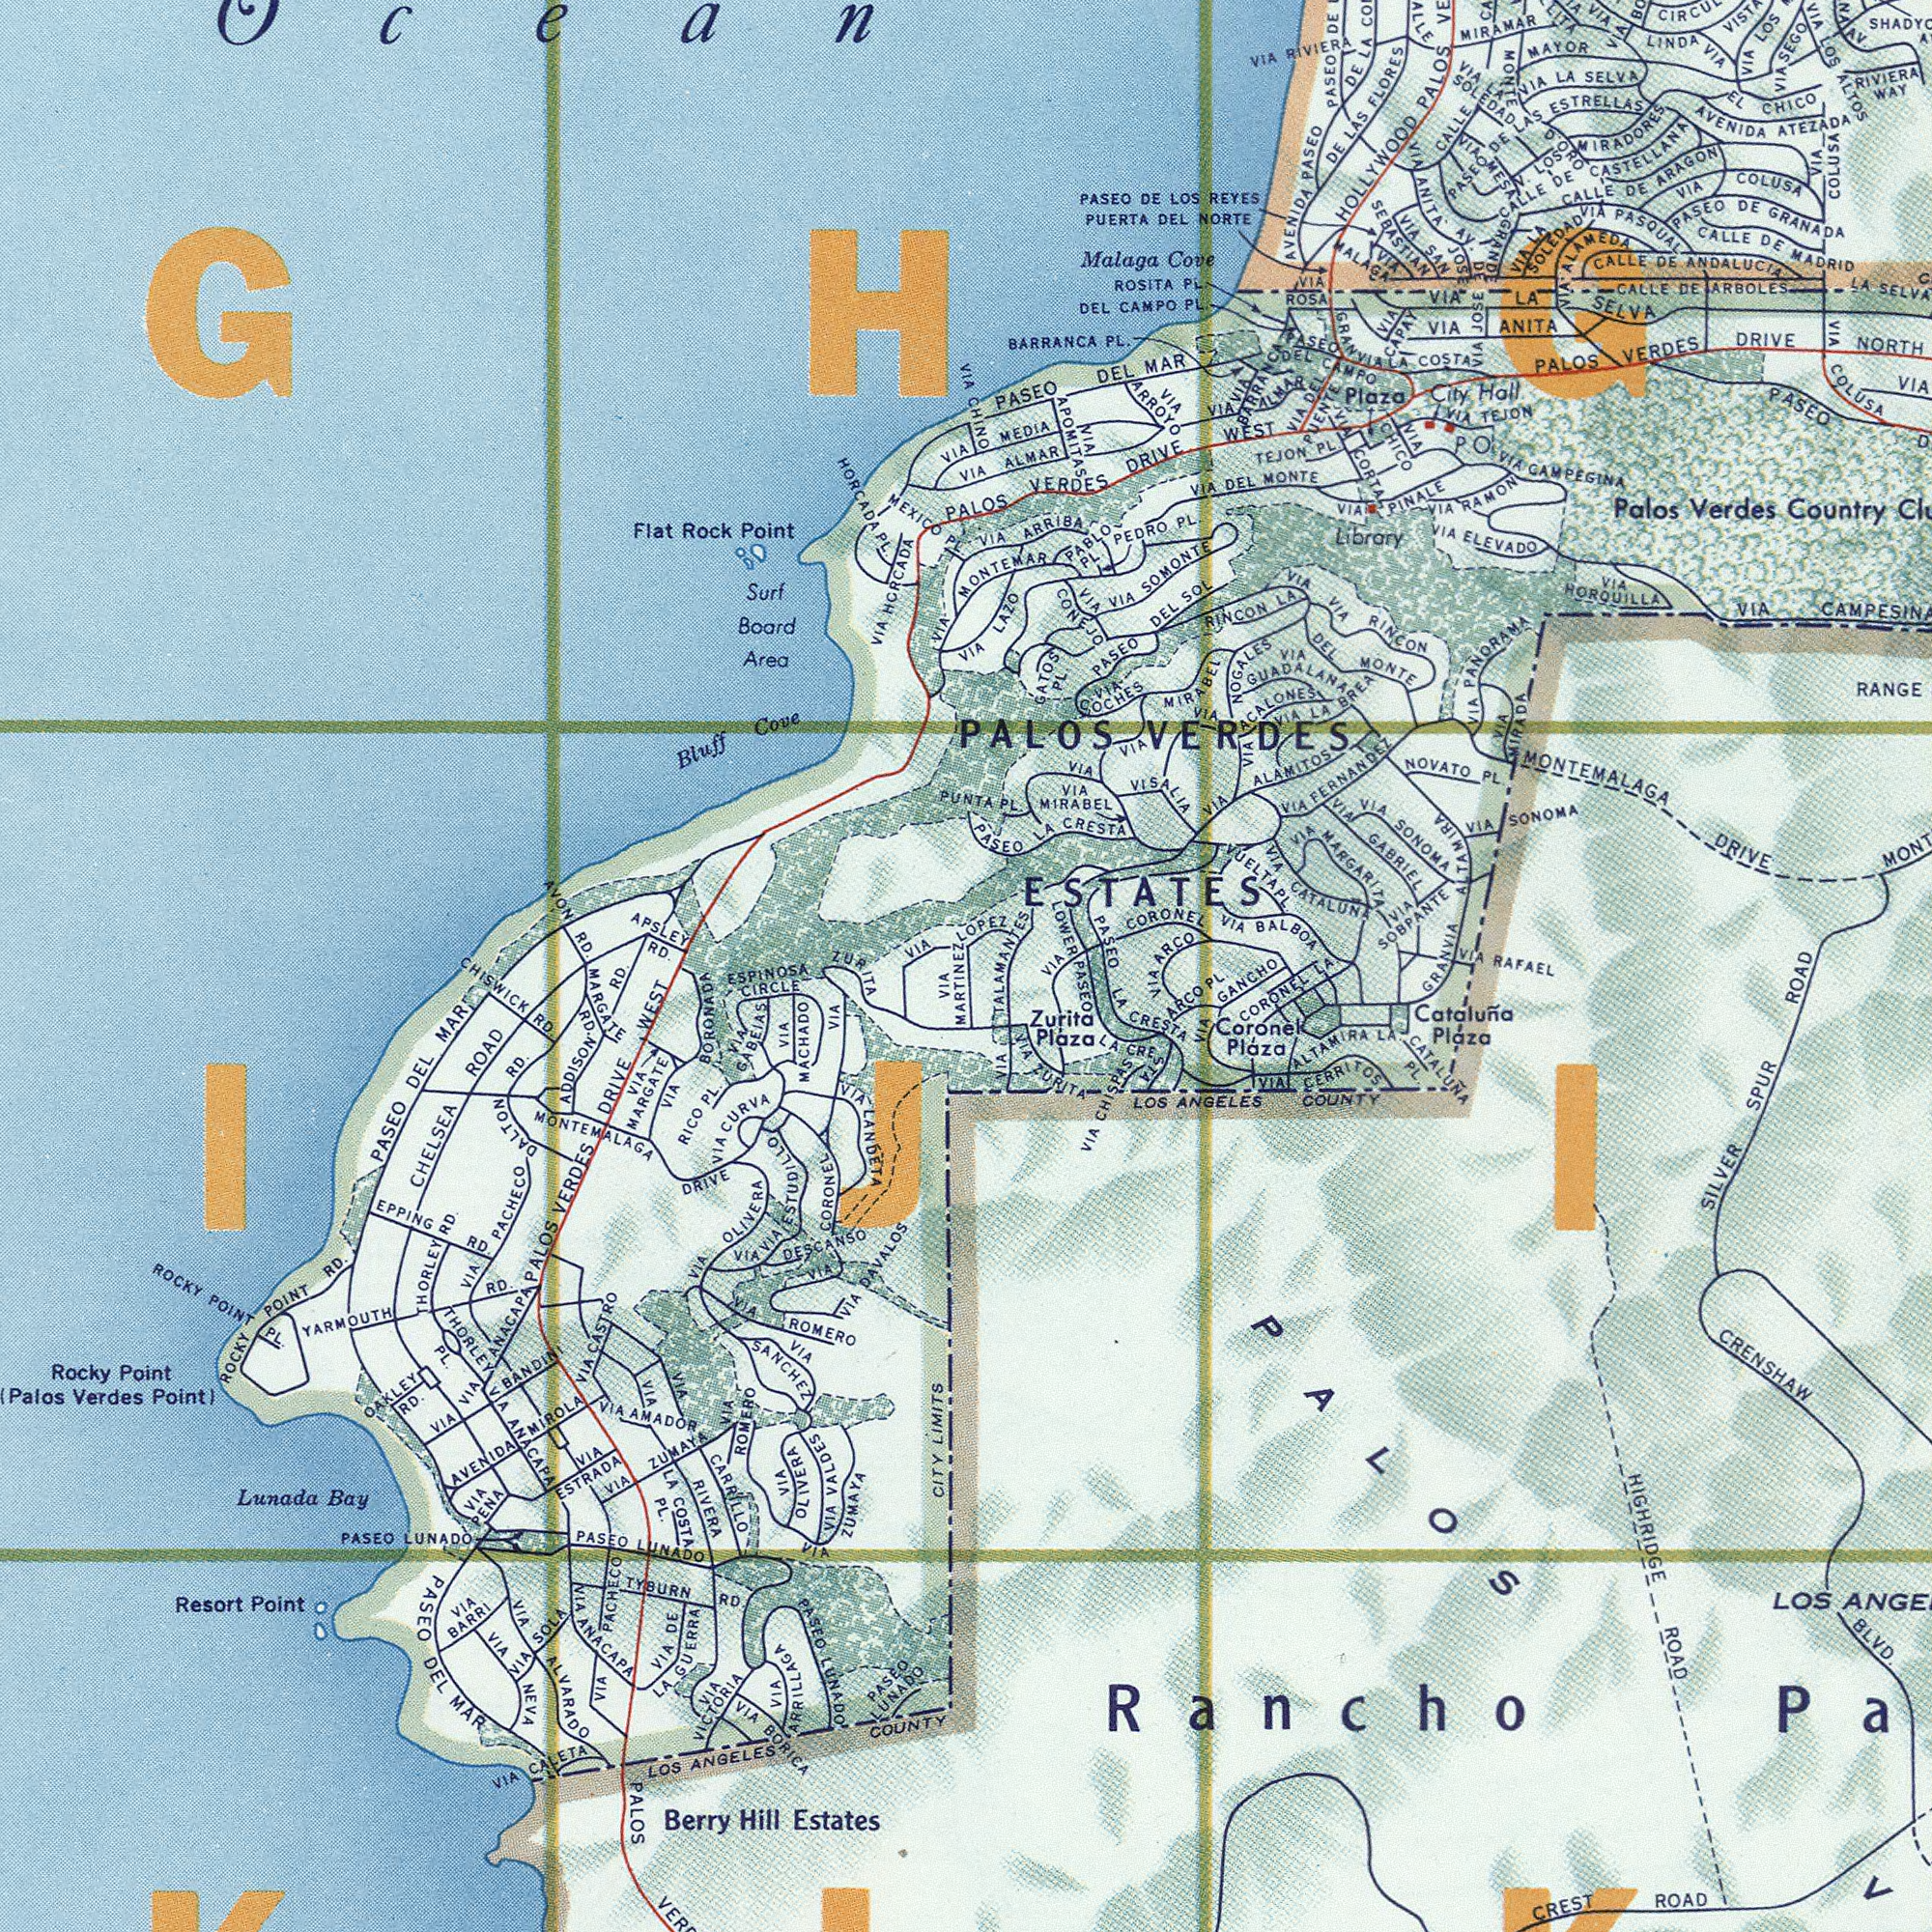What text is shown in the bottom-left quadrant? VIA VIA BORONADA VIA ALVARADO VIAAMADOR VIA RIVERA PASEO DEL MART VIA ANACAPA PALOS VERDES DRIVE WEST DALTON RD. Berry Hill Estates Lunada Bay ROCKY POINT RD. VIA CARRILLO VIA ROMERO VIA CORONEL OAKLEY RD. PASEO LUNADOL VIA BANDIN RICO PL. Rocky Point (Palos Verdes Point) CHELSEA ROAD VIA ZUMAYA VIA DAVALOS YARMOUTH RD. VIA DE PASEO LUNADO VIA MACHADO LOS ANGELES COUNTY MONTEMALAGA DRIVE CITY LIMITS VIA PACHECO PASEO LUNADO VIA OLIVERA LA COSTA PL. THORLEY RD. CHISWICK RD. EPPING RD. VIA SOLA VIA ZUMAYA PASEO DEL MAR TYBURN RD. PASEO LUNADO VIA PENA VIA ARRILLAGA ROCKY POINT PL. VIA ROMERO PALOS VER VIA OLIVERA VIA GABEIAS VIA PACHECO ADDISON RD. Resort Point VIA MARGATE VIA SANCHEL THORLEL PL. VIA ESTRADA VIA CASTRO VIA CURVA VIA NEVA VIA BARRI VIA ANACAPA VIA ANACAPA AVENIDA MIROLA MARGATE RD. ###IJI### VIA CALETA VIA BORICA VIA VICTORIA LA GUERRA VIA VALDES VIA ESTUDILLO VIA DESCANSO VIA LANDETA ESPINOSA CIRCLE VIA MARTINEZ What text is shown in the top-left quadrant? AVON RD. Surf Board Area Flat Rock Point Bluff Cove VIA HCRCADA APSLEY RD. ZU VIA MEXICO PL. PUNTA VIA HORCADA PL. VIA Ocean ###GHG### What text is shown in the bottom-right quadrant? LA CRESTA 4TA HIGHRIDGE ROAD Catoluña Pidza CRENSHAW BLVD. SILVER SPUR ROAD LOS LOS ANGELES COUNTY VIA TURITA CREST ROAD CATALUNA PL. VVAL CERRITOS Coronel Plaza Zurita Plaza VIA CHISPAS CORONEL LA VIA PASEO LA CRESTA ALTAMIRA LA. Rancho VIA GANCHO PALOS ARCO PL. What text is visible in the upper-right corner? MEDIA PL. ONTEMAR PALOS VERDES DRIVE WEST LOPEZ MONTEMALAGA DRIVE HOLLYWOOD PALOS VIA GABRIEL VIA CAMPESINA MIRAMAR VIA BALBOA VIA CATALUNA DE LAS FLORES CALLE DE ARBOLES PASEO DE LAS ESTRELLAS VIA COLUSA Palos Verdes Country Malaga Cove VUELTAPL VIA SONOMA VIA HOROUILLA VIA ALAMITOS PASEO DE GRANADA VIA GUADALAN VIA COLUSA VIA ARRIBA VIA RIVIERA PUERTA DEL NORTE PASEO DEL MAR AVENIDA PASEO VIA LAZO VIA CORTA PALOS VERDES DRIVE NORTH BARRANCA PL. VIA EL CHICO VIA ANITA VIA LA SELVA Librory VIA SOMONTE CALLE DE ARAGON PEDRO PL. VIA LOS PASEC VIA ALMAR CALLE DE ANDALUCIA CALLE MAYOR VIA MIRABEL LA VIA DEL MONTE NOVATO PL. VIA DEL MONTE PASEO PASEO LA CRESTA PASEO DEL SOL PASEO DE LOS REYES DEL CAMPO PL. VIA PINALE CALLE DE MADRID Plaza City Hall AVENIDA ATEZADA VIA SOBPANTE DE LA ARCO VIA ELEVADO VIA MIRABEL PASEOR DE DE VIA PASQUAL VIA PANDRAMA RINCON LA VIA FERNANDEL VIA LINDA VISTA VIA ROSA ROSITA PL. TALAMANTES LOWER VIA VIA ALAMEDA VIA LA SOLEDAD VIA COLUSA VIA LOS ALTOS AV. RIVIERA WAY VIA SEGO CIRCUL VIA MONTE VIA LA SELVA VIA LA SOLEDAD D ORO V. LOS MIRADORES CALLE DE CASTELLANA VIA MRSA GARNDE VIA ANITA AV. VIA JOSE VIA CHICO TEJON PL. VIA ALMAR VIA BARRANCA PASEO VIA DEL PUENTE PALOS VERDES ESTATES PABLO PL VIA APOMITAS VIA CHINO VIA ARROYO DE JOSE VIA SAN SEBASTIAN VIA MALAGA VIA CAPAY GRAN VIA LA COSTA VIA MIRADA VIA SONOMA VIA RAFAEL VIA CORONEL GRANVIA ALTAMIRA VIA MARGARITA VIA RINCON VIA LA BREA VIA NOGALES VIA ACALONES VIA VISALIA GATOS PL VIA CONEJO VIA COCHES VIA RAMON P VIA CAMPEGINA VIA TEJON DEL CAMPO 